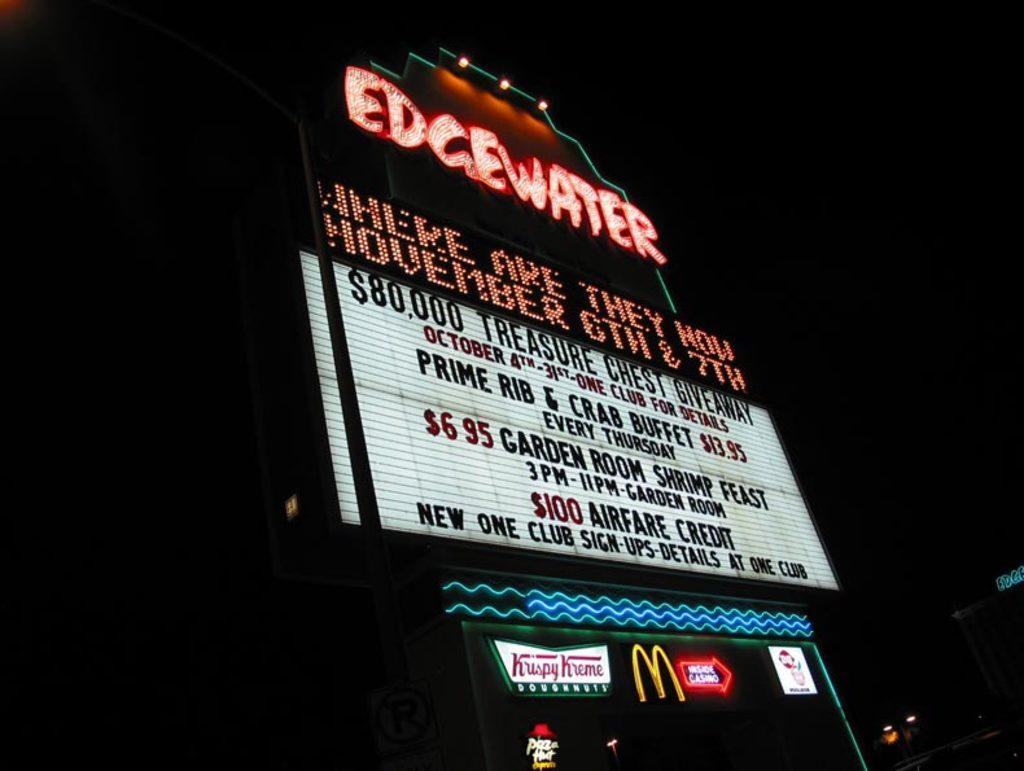<image>
Provide a brief description of the given image. A marquee sign that says EDGEWATER in bright red lights 